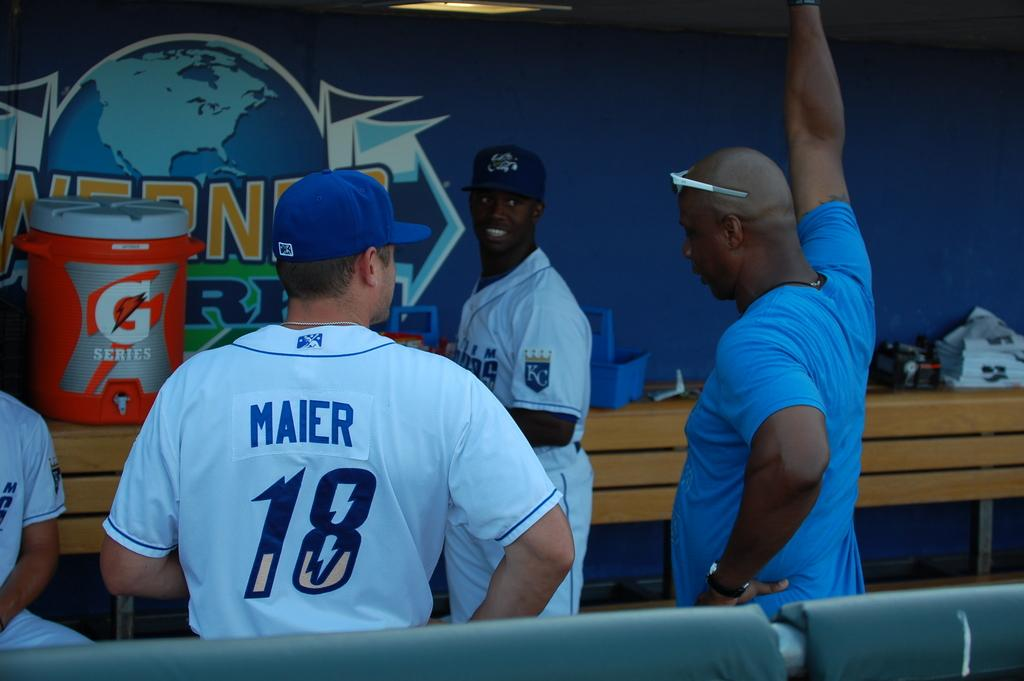Provide a one-sentence caption for the provided image. Baseball players talking to each other in the dugout area of a baseball field. 